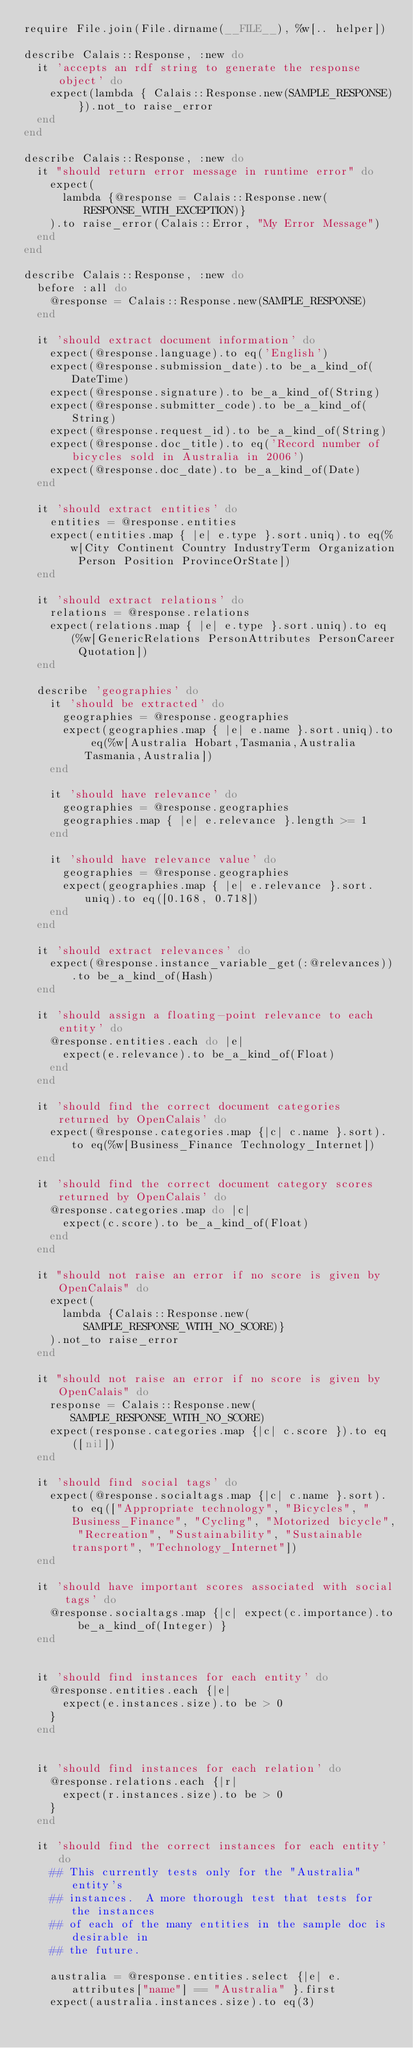Convert code to text. <code><loc_0><loc_0><loc_500><loc_500><_Ruby_>require File.join(File.dirname(__FILE__), %w[.. helper])

describe Calais::Response, :new do
  it 'accepts an rdf string to generate the response object' do
    expect(lambda { Calais::Response.new(SAMPLE_RESPONSE) }).not_to raise_error
  end
end

describe Calais::Response, :new do
  it "should return error message in runtime error" do
    expect(
      lambda {@response = Calais::Response.new(RESPONSE_WITH_EXCEPTION)}
    ).to raise_error(Calais::Error, "My Error Message")
  end
end

describe Calais::Response, :new do
  before :all do
    @response = Calais::Response.new(SAMPLE_RESPONSE)
  end

  it 'should extract document information' do
    expect(@response.language).to eq('English')
    expect(@response.submission_date).to be_a_kind_of(DateTime)
    expect(@response.signature).to be_a_kind_of(String)
    expect(@response.submitter_code).to be_a_kind_of(String)
    expect(@response.request_id).to be_a_kind_of(String)
    expect(@response.doc_title).to eq('Record number of bicycles sold in Australia in 2006')
    expect(@response.doc_date).to be_a_kind_of(Date)
  end

  it 'should extract entities' do
    entities = @response.entities
    expect(entities.map { |e| e.type }.sort.uniq).to eq(%w[City Continent Country IndustryTerm Organization Person Position ProvinceOrState])
  end

  it 'should extract relations' do
    relations = @response.relations
    expect(relations.map { |e| e.type }.sort.uniq).to eq(%w[GenericRelations PersonAttributes PersonCareer Quotation])
  end

  describe 'geographies' do
    it 'should be extracted' do
      geographies = @response.geographies
      expect(geographies.map { |e| e.name }.sort.uniq).to eq(%w[Australia Hobart,Tasmania,Australia Tasmania,Australia])
    end

    it 'should have relevance' do
      geographies = @response.geographies
      geographies.map { |e| e.relevance }.length >= 1
    end

    it 'should have relevance value' do
      geographies = @response.geographies
      expect(geographies.map { |e| e.relevance }.sort.uniq).to eq([0.168, 0.718])
    end
  end

  it 'should extract relevances' do
    expect(@response.instance_variable_get(:@relevances)).to be_a_kind_of(Hash)
  end

  it 'should assign a floating-point relevance to each entity' do
    @response.entities.each do |e|
      expect(e.relevance).to be_a_kind_of(Float)
    end
  end

  it 'should find the correct document categories returned by OpenCalais' do
    expect(@response.categories.map {|c| c.name }.sort).to eq(%w[Business_Finance Technology_Internet])
  end

  it 'should find the correct document category scores returned by OpenCalais' do
    @response.categories.map do |c|
      expect(c.score).to be_a_kind_of(Float)
    end
  end

  it "should not raise an error if no score is given by OpenCalais" do
    expect(
      lambda {Calais::Response.new(SAMPLE_RESPONSE_WITH_NO_SCORE)}
    ).not_to raise_error
  end

  it "should not raise an error if no score is given by OpenCalais" do
    response = Calais::Response.new(SAMPLE_RESPONSE_WITH_NO_SCORE)
    expect(response.categories.map {|c| c.score }).to eq([nil])
  end

  it 'should find social tags' do
    expect(@response.socialtags.map {|c| c.name }.sort).to eq(["Appropriate technology", "Bicycles", "Business_Finance", "Cycling", "Motorized bicycle", "Recreation", "Sustainability", "Sustainable transport", "Technology_Internet"])
  end

  it 'should have important scores associated with social tags' do
    @response.socialtags.map {|c| expect(c.importance).to be_a_kind_of(Integer) }
  end


  it 'should find instances for each entity' do
    @response.entities.each {|e|
      expect(e.instances.size).to be > 0
    }
  end


  it 'should find instances for each relation' do
    @response.relations.each {|r|
      expect(r.instances.size).to be > 0
    }
  end

  it 'should find the correct instances for each entity' do
    ## This currently tests only for the "Australia" entity's
    ## instances.  A more thorough test that tests for the instances
    ## of each of the many entities in the sample doc is desirable in
    ## the future.

    australia = @response.entities.select {|e| e.attributes["name"] == "Australia" }.first
    expect(australia.instances.size).to eq(3)</code> 